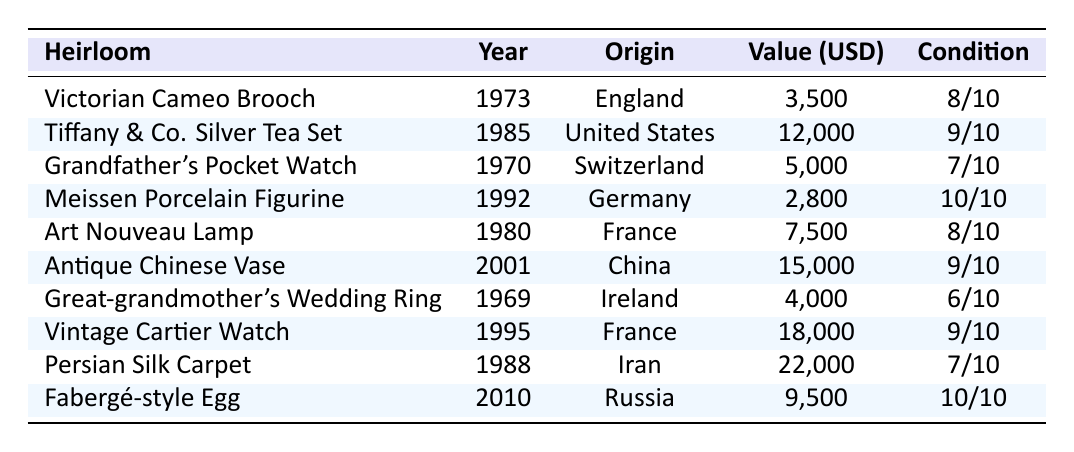What is the value of the Antique Chinese Vase? The table shows that the value of the Antique Chinese Vase is listed as 15,000 USD.
Answer: 15,000 USD Which heirloom has the highest value? By inspecting the value column, the Persian Silk Carpet is listed as having the highest value at 22,000 USD.
Answer: Persian Silk Carpet Did we acquire the Grandfather's Pocket Watch before the Victorian Cameo Brooch? The Grandfather's Pocket Watch was acquired in 1970, while the Victorian Cameo Brooch was acquired in 1973, confirming that it was acquired earlier.
Answer: Yes What is the average condition score of all heirlooms? To find the average, add all the condition scores (8 + 9 + 7 + 10 + 8 + 9 + 6 + 9 + 7 + 10 = 81) and divide by the number of heirlooms (10), resulting in an average of 8.1.
Answer: 8.1 How many heirlooms were acquired after the year 2000? There are two heirlooms acquired after 2000: the Antique Chinese Vase (2001) and the Fabergé-style Egg (2010).
Answer: 2 What is the total value of all heirlooms combined? Adding all the values (3,500 + 12,000 + 5,000 + 2,800 + 7,500 + 15,000 + 4,000 + 18,000 + 22,000 + 9,500) gives a total value of 97,300 USD.
Answer: 97,300 USD Which heirloom has the lowest condition score? The Great-grandmother's Wedding Ring has the lowest condition score of 6 out of 10.
Answer: Great-grandmother's Wedding Ring Is the Tiffany & Co. Silver Tea Set older than the Vintage Cartier Watch? The Tiffany & Co. Silver Tea Set was acquired in 1985, and the Vintage Cartier Watch was acquired in 1995, confirming that the Tea Set is indeed older.
Answer: Yes How much more is the value of the Vintage Cartier Watch compared to the Meissen Porcelain Figurine? The Vintage Cartier Watch is valued at 18,000 USD and the Meissen Porcelain Figurine at 2,800 USD. The difference is (18,000 - 2,800 = 15,200).
Answer: 15,200 USD Which country did we acquire the Art Nouveau Lamp from? The table indicates that the Art Nouveau Lamp was acquired from France.
Answer: France 